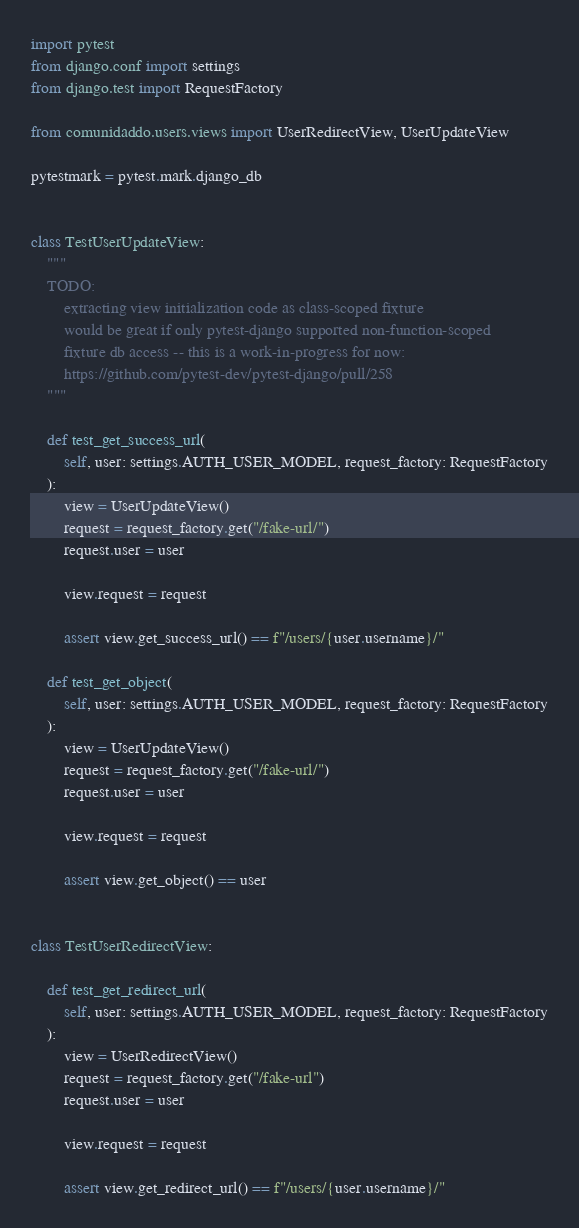Convert code to text. <code><loc_0><loc_0><loc_500><loc_500><_Python_>import pytest
from django.conf import settings
from django.test import RequestFactory

from comunidaddo.users.views import UserRedirectView, UserUpdateView

pytestmark = pytest.mark.django_db


class TestUserUpdateView:
    """
    TODO:
        extracting view initialization code as class-scoped fixture
        would be great if only pytest-django supported non-function-scoped
        fixture db access -- this is a work-in-progress for now:
        https://github.com/pytest-dev/pytest-django/pull/258
    """

    def test_get_success_url(
        self, user: settings.AUTH_USER_MODEL, request_factory: RequestFactory
    ):
        view = UserUpdateView()
        request = request_factory.get("/fake-url/")
        request.user = user

        view.request = request

        assert view.get_success_url() == f"/users/{user.username}/"

    def test_get_object(
        self, user: settings.AUTH_USER_MODEL, request_factory: RequestFactory
    ):
        view = UserUpdateView()
        request = request_factory.get("/fake-url/")
        request.user = user

        view.request = request

        assert view.get_object() == user


class TestUserRedirectView:

    def test_get_redirect_url(
        self, user: settings.AUTH_USER_MODEL, request_factory: RequestFactory
    ):
        view = UserRedirectView()
        request = request_factory.get("/fake-url")
        request.user = user

        view.request = request

        assert view.get_redirect_url() == f"/users/{user.username}/"
</code> 